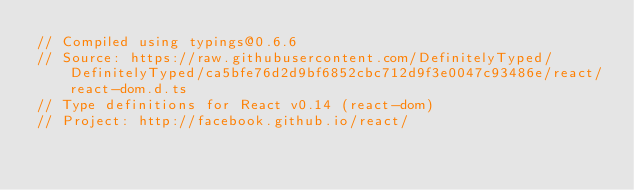Convert code to text. <code><loc_0><loc_0><loc_500><loc_500><_TypeScript_>// Compiled using typings@0.6.6
// Source: https://raw.githubusercontent.com/DefinitelyTyped/DefinitelyTyped/ca5bfe76d2d9bf6852cbc712d9f3e0047c93486e/react/react-dom.d.ts
// Type definitions for React v0.14 (react-dom)
// Project: http://facebook.github.io/react/</code> 